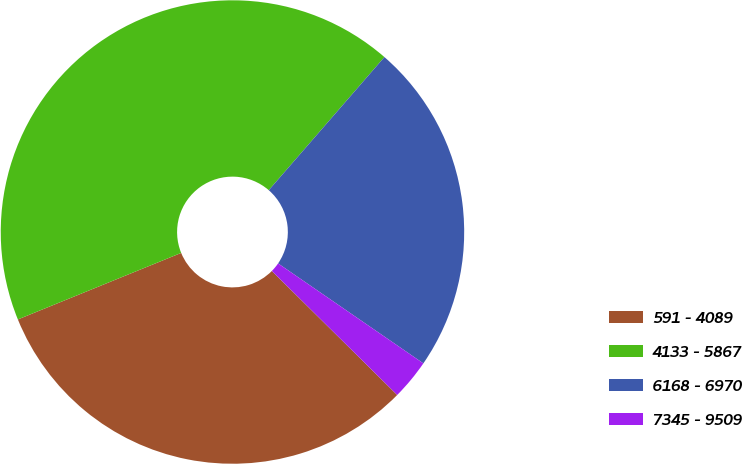Convert chart to OTSL. <chart><loc_0><loc_0><loc_500><loc_500><pie_chart><fcel>591 - 4089<fcel>4133 - 5867<fcel>6168 - 6970<fcel>7345 - 9509<nl><fcel>31.43%<fcel>42.54%<fcel>23.21%<fcel>2.82%<nl></chart> 